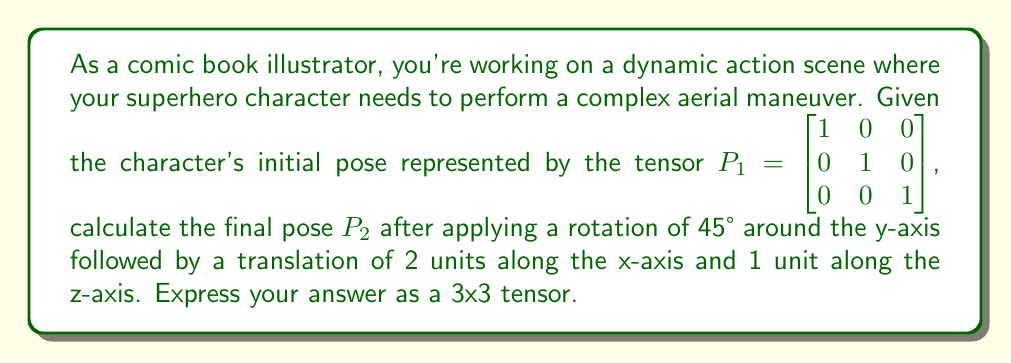Could you help me with this problem? Let's approach this step-by-step:

1) First, we need to create the rotation matrix for a 45° rotation around the y-axis:

   $$R_y(45°) = \begin{bmatrix} \cos(45°) & 0 & \sin(45°) \\ 0 & 1 & 0 \\ -\sin(45°) & 0 & \cos(45°) \end{bmatrix} = \begin{bmatrix} \frac{\sqrt{2}}{2} & 0 & \frac{\sqrt{2}}{2} \\ 0 & 1 & 0 \\ -\frac{\sqrt{2}}{2} & 0 & \frac{\sqrt{2}}{2} \end{bmatrix}$$

2) Next, we apply this rotation to the initial pose:

   $$P_{rotated} = P_1 \cdot R_y(45°) = \begin{bmatrix} 1 & 0 & 0 \\ 0 & 1 & 0 \\ 0 & 0 & 1 \end{bmatrix} \cdot \begin{bmatrix} \frac{\sqrt{2}}{2} & 0 & \frac{\sqrt{2}}{2} \\ 0 & 1 & 0 \\ -\frac{\sqrt{2}}{2} & 0 & \frac{\sqrt{2}}{2} \end{bmatrix} = \begin{bmatrix} \frac{\sqrt{2}}{2} & 0 & \frac{\sqrt{2}}{2} \\ 0 & 1 & 0 \\ -\frac{\sqrt{2}}{2} & 0 & \frac{\sqrt{2}}{2} \end{bmatrix}$$

3) Now, we need to apply the translation. In tensor form, we can represent this as:

   $$T = \begin{bmatrix} 1 & 0 & 0 \\ 0 & 1 & 0 \\ 2 & 0 & 1 \end{bmatrix}$$

   Note that the translation is represented in the last row, with 2 units along x and 1 unit along z.

4) Finally, we apply this translation to our rotated pose:

   $$P_2 = P_{rotated} \cdot T = \begin{bmatrix} \frac{\sqrt{2}}{2} & 0 & \frac{\sqrt{2}}{2} \\ 0 & 1 & 0 \\ -\frac{\sqrt{2}}{2} & 0 & \frac{\sqrt{2}}{2} \end{bmatrix} \cdot \begin{bmatrix} 1 & 0 & 0 \\ 0 & 1 & 0 \\ 2 & 0 & 1 \end{bmatrix}$$

5) Multiplying these matrices:

   $$P_2 = \begin{bmatrix} \frac{\sqrt{2}}{2} + \sqrt{2} & 0 & \frac{\sqrt{2}}{2} \\ 0 & 1 & 0 \\ -\frac{\sqrt{2}}{2} + \sqrt{2} & 0 & \frac{\sqrt{2}}{2} \end{bmatrix}$$

This final tensor $P_2$ represents the character's pose after the rotation and translation.
Answer: $$P_2 = \begin{bmatrix} \frac{\sqrt{2}}{2} + \sqrt{2} & 0 & \frac{\sqrt{2}}{2} \\ 0 & 1 & 0 \\ -\frac{\sqrt{2}}{2} + \sqrt{2} & 0 & \frac{\sqrt{2}}{2} \end{bmatrix}$$ 